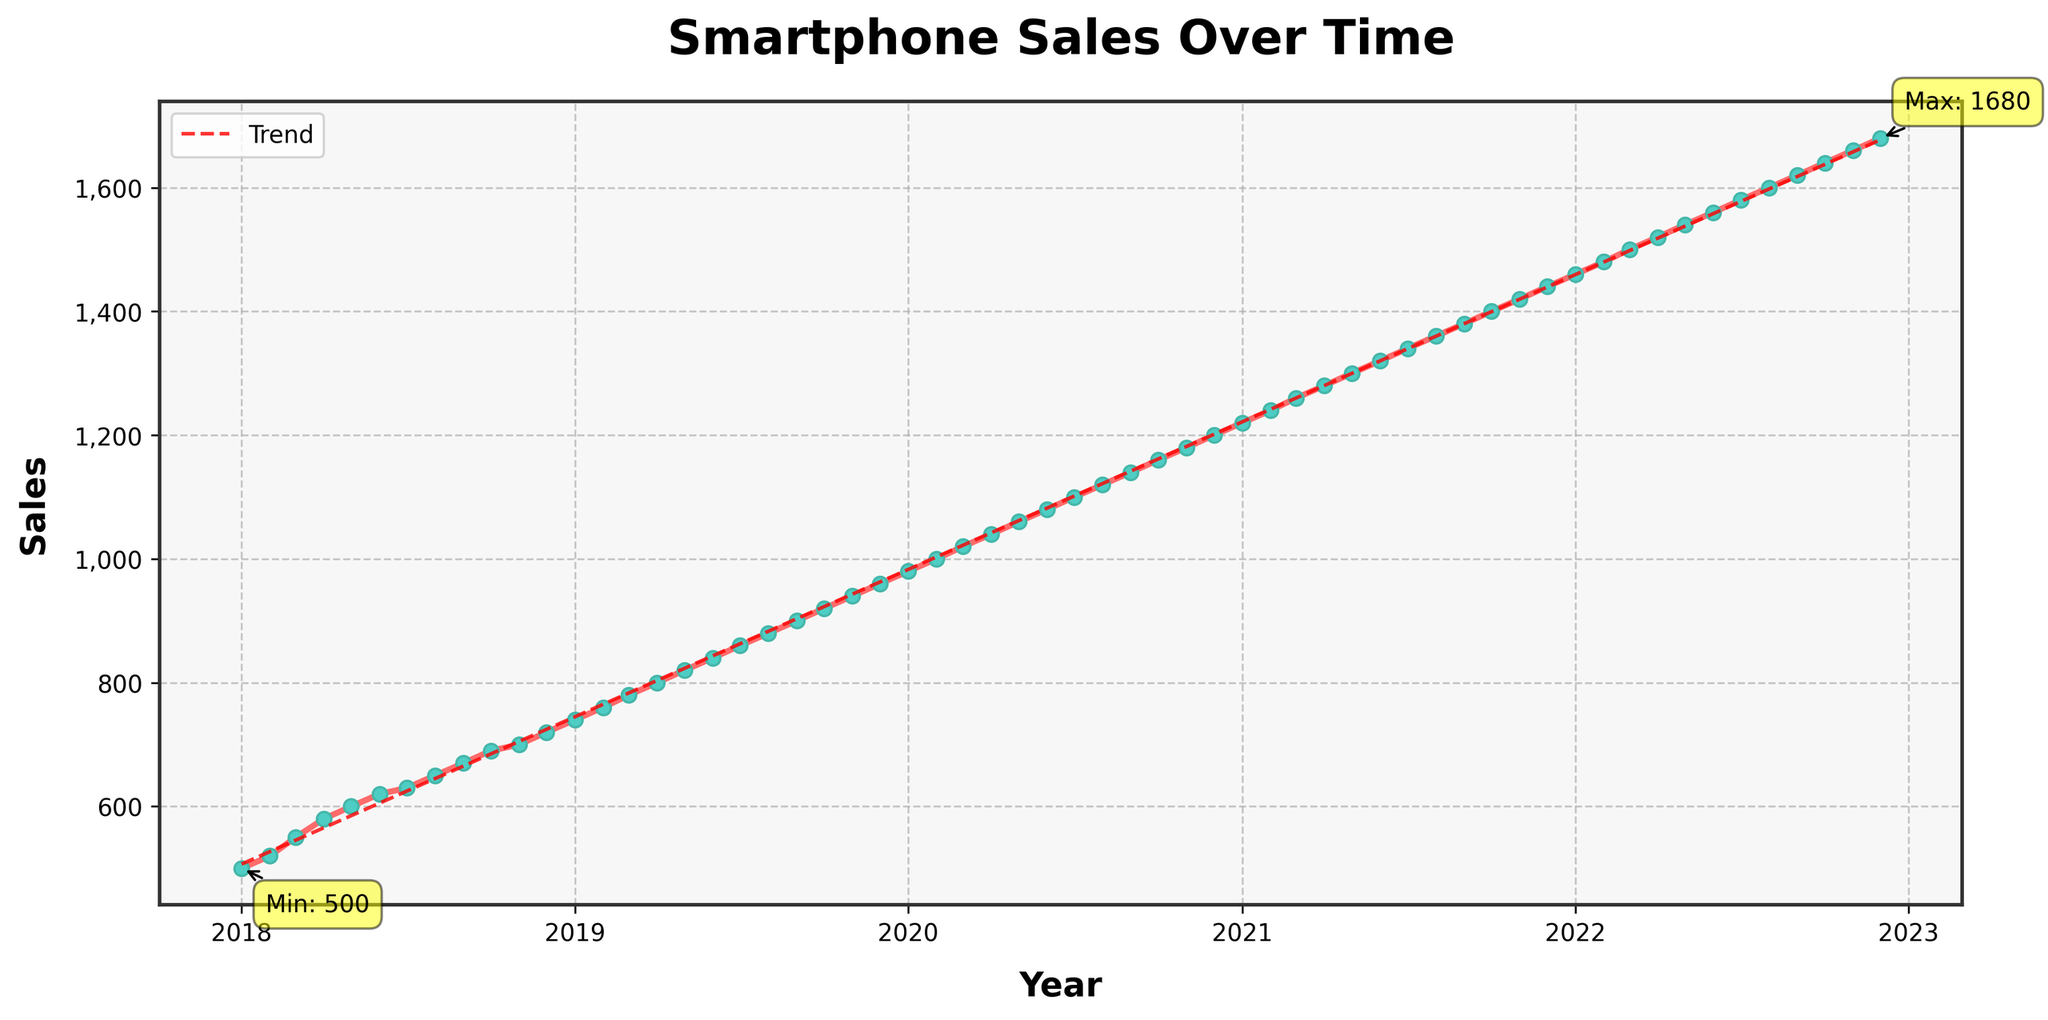what is the title of the plot? The title is the text at the top of the plot. Looking at the figure, the title reads "Smartphone Sales Over Time".
Answer: Smartphone Sales Over Time What are the highest and lowest sales values, and when did they occur? From the plot, the highest sales value is annotated as 1680 in December 2022, and the lowest is 500 in January 2018. These points are marked with annotations.
Answer: Highest: 1680 in December 2022, Lowest: 500 in January 2018 How does the sales trend change over the years? A trend line is plotted in the figure, which shows the sales increasing steadily over time without any major dips or fluctuations. This indicates a consistent upward trend in sales over the years.
Answer: Consistent upward trend In which year did the sales first exceed 1000 units? By observing the plotted data, we can see that the sales first exceeded 1000 units in February 2020.
Answer: February 2020 What is the approximate average increase in sales per month? The sales start at 500 units and grow to 1680 units over 5 years. This gives an increase of (1680 - 500) = 1180 units over 60 months, resulting in an average increase of approximately 1180/60 = 19.67 units per month.
Answer: 19.67 units per month What is the general trend before and after the trend line in the graph? The general trend before the trend line and after the trend line consistently shows an increasing pattern, indicating rising sales over time.
Answer: Increasing pattern Is there any seasonal variation in sales data? The plot does not distinctly show any seasonal variation; instead, it shows a steady growth pattern across all months and years. We do not observe any periodic fluctuations or dips that would point to seasonality.
Answer: No seasonal variation How do the sales figures in 2021 compare to those in 2020? By comparing the sales values from the plot for 2020 and 2021, we see that sales continue to increase each month in both years, rising from 960 in December 2020 to 1440 in December 2021.
Answer: 2021 sales are higher than 2020 sales How do sales in December 2019 compare to those in December 2022? From the figure, the sales increased from 960 in December 2019 to 1680 in December 2022. This shows a significant increase over the three-year period.
Answer: Increased by 720 units What can be inferred about the relationship between sales and time from the trend line? The trend line in the plot is upward sloping, indicating a positive correlation between sales and time. As time progresses, sales consistently increase.
Answer: Positive correlation, increasing sales over time 